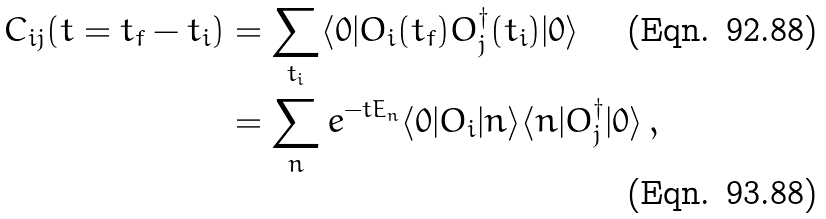Convert formula to latex. <formula><loc_0><loc_0><loc_500><loc_500>C _ { i j } ( t = t _ { f } - t _ { i } ) & = \sum _ { t _ { i } } \langle 0 | O _ { i } ( t _ { f } ) O _ { j } ^ { \dagger } ( t _ { i } ) | 0 \rangle \\ & = \sum _ { n } e ^ { - t E _ { n } } \langle 0 | O _ { i } | n \rangle \langle n | O _ { j } ^ { \dagger } | 0 \rangle \, ,</formula> 